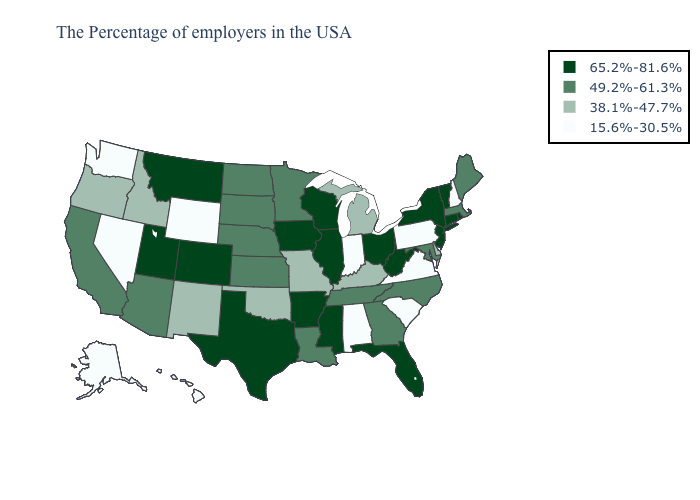Does Arkansas have the same value as Wisconsin?
Concise answer only. Yes. Name the states that have a value in the range 15.6%-30.5%?
Concise answer only. New Hampshire, Pennsylvania, Virginia, South Carolina, Indiana, Alabama, Wyoming, Nevada, Washington, Alaska, Hawaii. Does New York have the highest value in the Northeast?
Short answer required. Yes. Does Pennsylvania have the lowest value in the Northeast?
Concise answer only. Yes. What is the lowest value in the USA?
Give a very brief answer. 15.6%-30.5%. Name the states that have a value in the range 49.2%-61.3%?
Quick response, please. Maine, Massachusetts, Maryland, North Carolina, Georgia, Tennessee, Louisiana, Minnesota, Kansas, Nebraska, South Dakota, North Dakota, Arizona, California. Does New Hampshire have the lowest value in the Northeast?
Write a very short answer. Yes. What is the value of Massachusetts?
Keep it brief. 49.2%-61.3%. What is the value of Georgia?
Give a very brief answer. 49.2%-61.3%. How many symbols are there in the legend?
Answer briefly. 4. Among the states that border Connecticut , which have the highest value?
Keep it brief. Rhode Island, New York. Among the states that border Wyoming , does Montana have the lowest value?
Give a very brief answer. No. Does Wyoming have the lowest value in the West?
Keep it brief. Yes. Which states have the lowest value in the Northeast?
Give a very brief answer. New Hampshire, Pennsylvania. Name the states that have a value in the range 65.2%-81.6%?
Write a very short answer. Rhode Island, Vermont, Connecticut, New York, New Jersey, West Virginia, Ohio, Florida, Wisconsin, Illinois, Mississippi, Arkansas, Iowa, Texas, Colorado, Utah, Montana. 